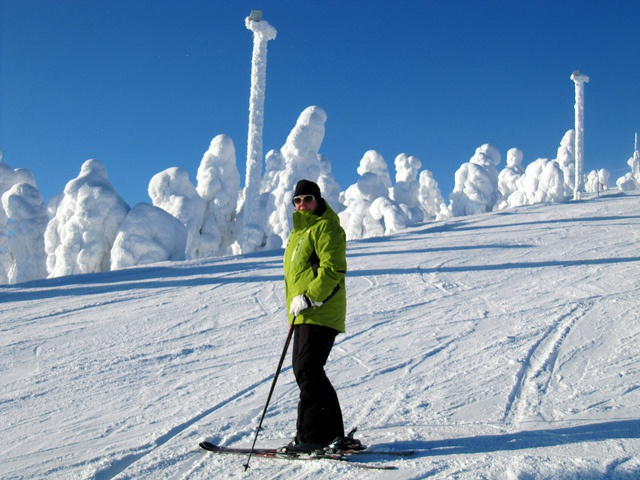Describe the objects in this image and their specific colors. I can see people in blue, black, darkgreen, and olive tones and skis in blue, black, gray, and darkgray tones in this image. 